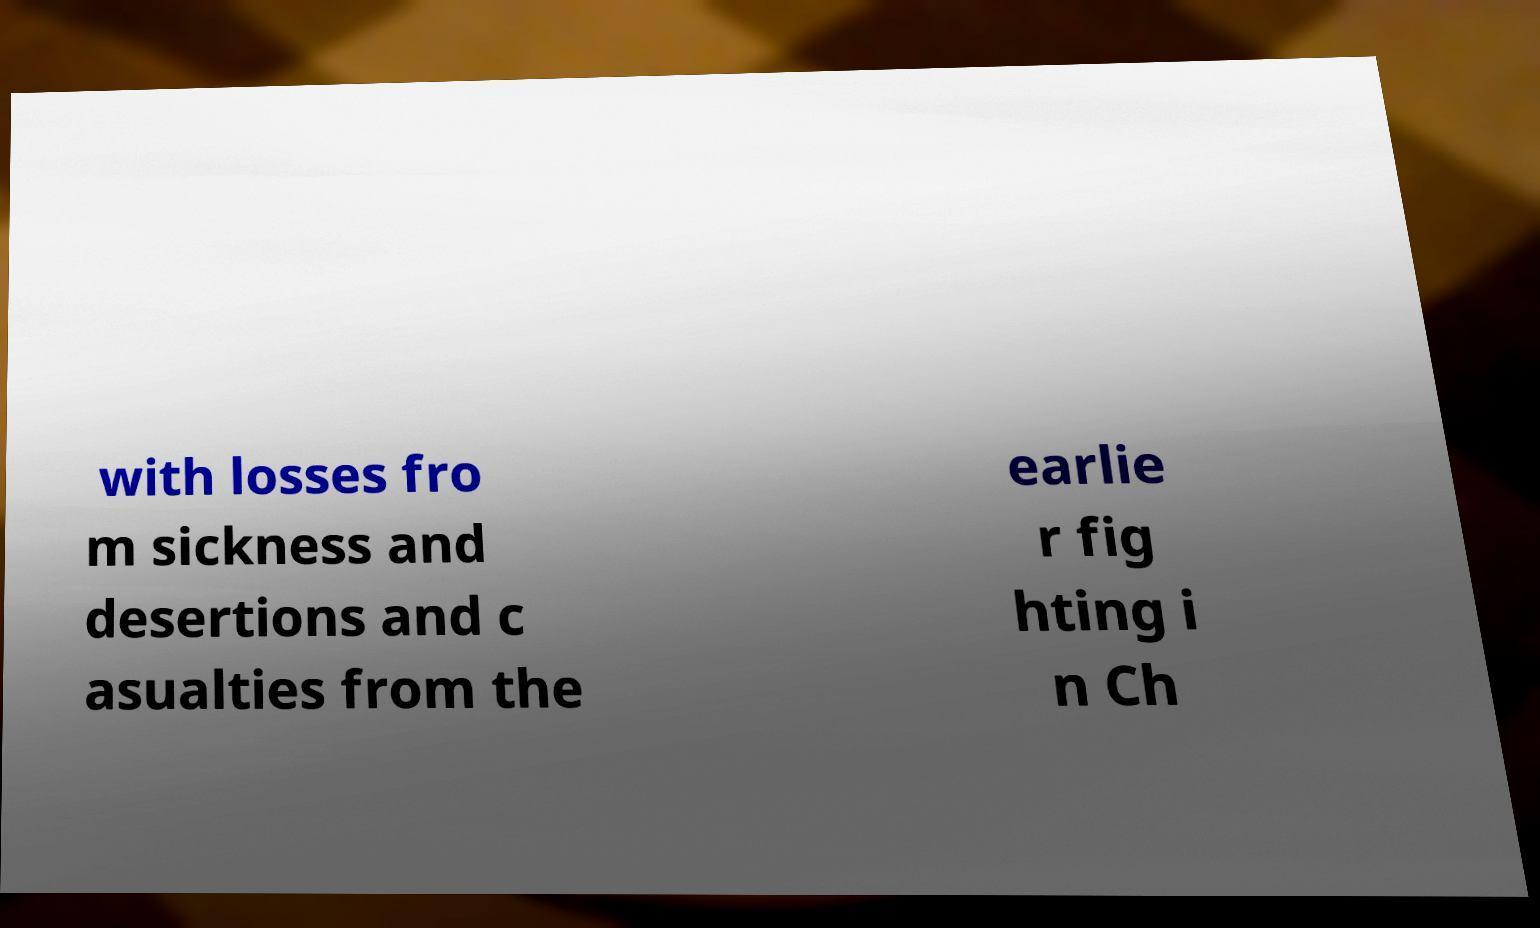There's text embedded in this image that I need extracted. Can you transcribe it verbatim? with losses fro m sickness and desertions and c asualties from the earlie r fig hting i n Ch 